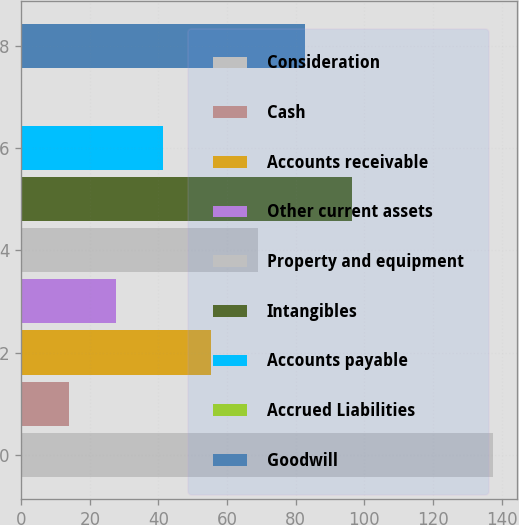Convert chart to OTSL. <chart><loc_0><loc_0><loc_500><loc_500><bar_chart><fcel>Consideration<fcel>Cash<fcel>Accounts receivable<fcel>Other current assets<fcel>Property and equipment<fcel>Intangibles<fcel>Accounts payable<fcel>Accrued Liabilities<fcel>Goodwill<nl><fcel>137.6<fcel>13.94<fcel>55.16<fcel>27.68<fcel>68.9<fcel>96.38<fcel>41.42<fcel>0.2<fcel>82.64<nl></chart> 